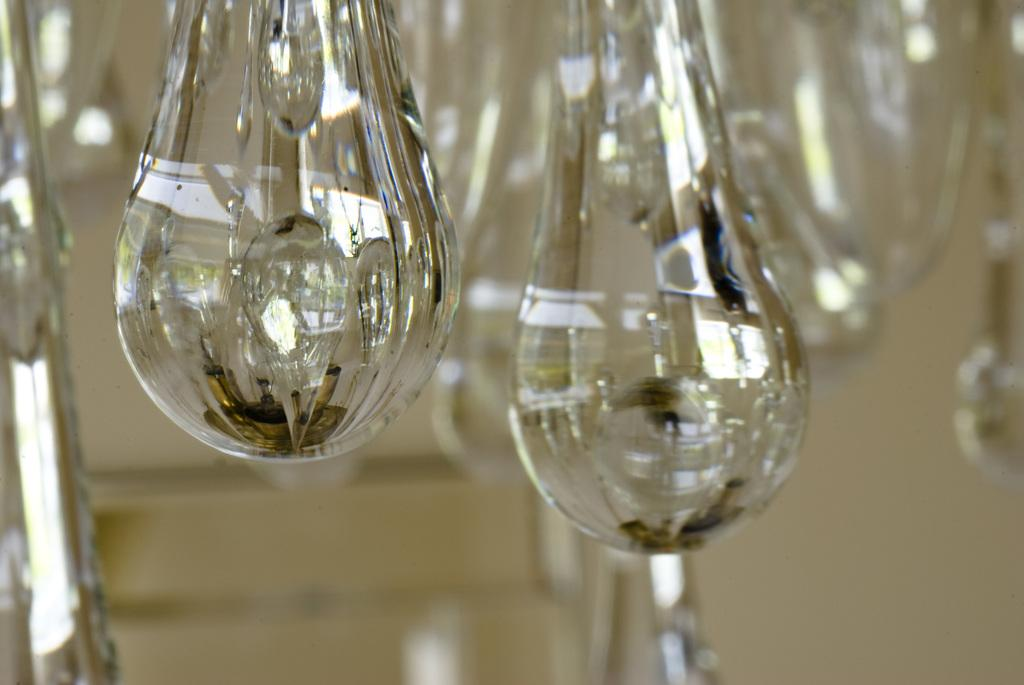What type of objects can be seen in the image? There are glass objects in the image. What can be observed on the surface of the glass objects? There are reflections on the glass objects. Can you see any horses running along the river in the image? There is no river or horses present in the image; it only features glass objects with reflections. Is there a notebook visible in the image? There is no notebook present in the image; it only features glass objects with reflections. 